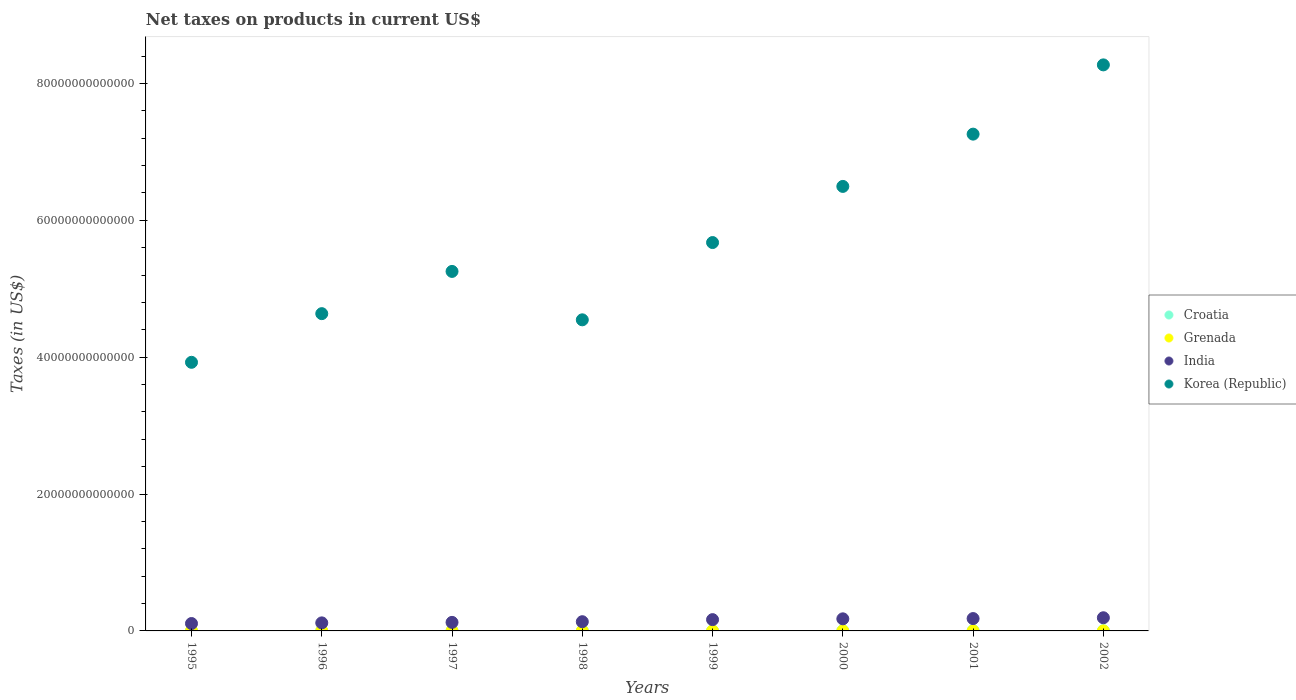How many different coloured dotlines are there?
Your answer should be very brief. 4. What is the net taxes on products in India in 1997?
Make the answer very short. 1.25e+12. Across all years, what is the maximum net taxes on products in Croatia?
Offer a very short reply. 3.54e+1. Across all years, what is the minimum net taxes on products in Grenada?
Offer a very short reply. 1.16e+08. In which year was the net taxes on products in Croatia maximum?
Your answer should be very brief. 2002. What is the total net taxes on products in India in the graph?
Your response must be concise. 1.20e+13. What is the difference between the net taxes on products in Grenada in 1998 and that in 2001?
Keep it short and to the point. -3.16e+07. What is the difference between the net taxes on products in Grenada in 1997 and the net taxes on products in Korea (Republic) in 2000?
Your response must be concise. -6.50e+13. What is the average net taxes on products in Korea (Republic) per year?
Provide a succinct answer. 5.76e+13. In the year 1995, what is the difference between the net taxes on products in India and net taxes on products in Korea (Republic)?
Provide a short and direct response. -3.82e+13. In how many years, is the net taxes on products in Grenada greater than 40000000000000 US$?
Make the answer very short. 0. What is the ratio of the net taxes on products in India in 1998 to that in 2002?
Keep it short and to the point. 0.7. Is the difference between the net taxes on products in India in 1998 and 2000 greater than the difference between the net taxes on products in Korea (Republic) in 1998 and 2000?
Provide a succinct answer. Yes. What is the difference between the highest and the second highest net taxes on products in Croatia?
Provide a short and direct response. 2.80e+09. What is the difference between the highest and the lowest net taxes on products in Croatia?
Offer a terse response. 1.59e+1. In how many years, is the net taxes on products in Korea (Republic) greater than the average net taxes on products in Korea (Republic) taken over all years?
Ensure brevity in your answer.  3. Is it the case that in every year, the sum of the net taxes on products in Croatia and net taxes on products in India  is greater than the sum of net taxes on products in Grenada and net taxes on products in Korea (Republic)?
Your response must be concise. No. Is it the case that in every year, the sum of the net taxes on products in India and net taxes on products in Grenada  is greater than the net taxes on products in Korea (Republic)?
Offer a terse response. No. Does the net taxes on products in Croatia monotonically increase over the years?
Provide a short and direct response. Yes. How many dotlines are there?
Offer a very short reply. 4. How many years are there in the graph?
Your answer should be very brief. 8. What is the difference between two consecutive major ticks on the Y-axis?
Give a very brief answer. 2.00e+13. Are the values on the major ticks of Y-axis written in scientific E-notation?
Your response must be concise. No. Does the graph contain any zero values?
Ensure brevity in your answer.  No. Does the graph contain grids?
Offer a terse response. No. What is the title of the graph?
Your answer should be very brief. Net taxes on products in current US$. Does "Ethiopia" appear as one of the legend labels in the graph?
Offer a very short reply. No. What is the label or title of the X-axis?
Provide a succinct answer. Years. What is the label or title of the Y-axis?
Provide a succinct answer. Taxes (in US$). What is the Taxes (in US$) in Croatia in 1995?
Your response must be concise. 1.95e+1. What is the Taxes (in US$) in Grenada in 1995?
Ensure brevity in your answer.  1.16e+08. What is the Taxes (in US$) in India in 1995?
Make the answer very short. 1.08e+12. What is the Taxes (in US$) in Korea (Republic) in 1995?
Make the answer very short. 3.93e+13. What is the Taxes (in US$) of Croatia in 1996?
Offer a very short reply. 1.99e+1. What is the Taxes (in US$) in Grenada in 1996?
Make the answer very short. 1.32e+08. What is the Taxes (in US$) of India in 1996?
Your answer should be very brief. 1.17e+12. What is the Taxes (in US$) in Korea (Republic) in 1996?
Your answer should be compact. 4.64e+13. What is the Taxes (in US$) of Croatia in 1997?
Your response must be concise. 2.29e+1. What is the Taxes (in US$) in Grenada in 1997?
Ensure brevity in your answer.  1.44e+08. What is the Taxes (in US$) of India in 1997?
Make the answer very short. 1.25e+12. What is the Taxes (in US$) in Korea (Republic) in 1997?
Keep it short and to the point. 5.25e+13. What is the Taxes (in US$) of Croatia in 1998?
Provide a short and direct response. 2.65e+1. What is the Taxes (in US$) of Grenada in 1998?
Your answer should be compact. 1.50e+08. What is the Taxes (in US$) of India in 1998?
Provide a short and direct response. 1.35e+12. What is the Taxes (in US$) of Korea (Republic) in 1998?
Make the answer very short. 4.55e+13. What is the Taxes (in US$) in Croatia in 1999?
Ensure brevity in your answer.  2.66e+1. What is the Taxes (in US$) of Grenada in 1999?
Your answer should be compact. 1.86e+08. What is the Taxes (in US$) in India in 1999?
Your response must be concise. 1.65e+12. What is the Taxes (in US$) in Korea (Republic) in 1999?
Offer a terse response. 5.68e+13. What is the Taxes (in US$) of Croatia in 2000?
Keep it short and to the point. 3.02e+1. What is the Taxes (in US$) in Grenada in 2000?
Give a very brief answer. 1.93e+08. What is the Taxes (in US$) of India in 2000?
Your answer should be very brief. 1.77e+12. What is the Taxes (in US$) in Korea (Republic) in 2000?
Provide a succinct answer. 6.50e+13. What is the Taxes (in US$) of Croatia in 2001?
Offer a terse response. 3.26e+1. What is the Taxes (in US$) of Grenada in 2001?
Your answer should be very brief. 1.82e+08. What is the Taxes (in US$) of India in 2001?
Your answer should be very brief. 1.81e+12. What is the Taxes (in US$) in Korea (Republic) in 2001?
Provide a succinct answer. 7.26e+13. What is the Taxes (in US$) in Croatia in 2002?
Keep it short and to the point. 3.54e+1. What is the Taxes (in US$) of Grenada in 2002?
Provide a short and direct response. 1.90e+08. What is the Taxes (in US$) of India in 2002?
Your answer should be very brief. 1.92e+12. What is the Taxes (in US$) of Korea (Republic) in 2002?
Keep it short and to the point. 8.27e+13. Across all years, what is the maximum Taxes (in US$) of Croatia?
Offer a terse response. 3.54e+1. Across all years, what is the maximum Taxes (in US$) of Grenada?
Offer a terse response. 1.93e+08. Across all years, what is the maximum Taxes (in US$) of India?
Offer a very short reply. 1.92e+12. Across all years, what is the maximum Taxes (in US$) in Korea (Republic)?
Keep it short and to the point. 8.27e+13. Across all years, what is the minimum Taxes (in US$) in Croatia?
Make the answer very short. 1.95e+1. Across all years, what is the minimum Taxes (in US$) in Grenada?
Give a very brief answer. 1.16e+08. Across all years, what is the minimum Taxes (in US$) of India?
Keep it short and to the point. 1.08e+12. Across all years, what is the minimum Taxes (in US$) in Korea (Republic)?
Your response must be concise. 3.93e+13. What is the total Taxes (in US$) in Croatia in the graph?
Make the answer very short. 2.14e+11. What is the total Taxes (in US$) in Grenada in the graph?
Your answer should be compact. 1.29e+09. What is the total Taxes (in US$) of India in the graph?
Make the answer very short. 1.20e+13. What is the total Taxes (in US$) of Korea (Republic) in the graph?
Provide a succinct answer. 4.61e+14. What is the difference between the Taxes (in US$) in Croatia in 1995 and that in 1996?
Give a very brief answer. -3.94e+08. What is the difference between the Taxes (in US$) of Grenada in 1995 and that in 1996?
Offer a very short reply. -1.65e+07. What is the difference between the Taxes (in US$) in India in 1995 and that in 1996?
Your response must be concise. -9.35e+1. What is the difference between the Taxes (in US$) in Korea (Republic) in 1995 and that in 1996?
Make the answer very short. -7.11e+12. What is the difference between the Taxes (in US$) in Croatia in 1995 and that in 1997?
Make the answer very short. -3.39e+09. What is the difference between the Taxes (in US$) in Grenada in 1995 and that in 1997?
Provide a short and direct response. -2.83e+07. What is the difference between the Taxes (in US$) of India in 1995 and that in 1997?
Provide a short and direct response. -1.66e+11. What is the difference between the Taxes (in US$) of Korea (Republic) in 1995 and that in 1997?
Keep it short and to the point. -1.33e+13. What is the difference between the Taxes (in US$) of Croatia in 1995 and that in 1998?
Make the answer very short. -7.04e+09. What is the difference between the Taxes (in US$) in Grenada in 1995 and that in 1998?
Keep it short and to the point. -3.43e+07. What is the difference between the Taxes (in US$) of India in 1995 and that in 1998?
Offer a very short reply. -2.65e+11. What is the difference between the Taxes (in US$) in Korea (Republic) in 1995 and that in 1998?
Offer a terse response. -6.21e+12. What is the difference between the Taxes (in US$) in Croatia in 1995 and that in 1999?
Provide a succinct answer. -7.07e+09. What is the difference between the Taxes (in US$) of Grenada in 1995 and that in 1999?
Ensure brevity in your answer.  -7.06e+07. What is the difference between the Taxes (in US$) of India in 1995 and that in 1999?
Your answer should be compact. -5.68e+11. What is the difference between the Taxes (in US$) of Korea (Republic) in 1995 and that in 1999?
Your response must be concise. -1.75e+13. What is the difference between the Taxes (in US$) in Croatia in 1995 and that in 2000?
Provide a succinct answer. -1.07e+1. What is the difference between the Taxes (in US$) in Grenada in 1995 and that in 2000?
Your answer should be very brief. -7.71e+07. What is the difference between the Taxes (in US$) of India in 1995 and that in 2000?
Your response must be concise. -6.85e+11. What is the difference between the Taxes (in US$) in Korea (Republic) in 1995 and that in 2000?
Keep it short and to the point. -2.57e+13. What is the difference between the Taxes (in US$) in Croatia in 1995 and that in 2001?
Offer a terse response. -1.31e+1. What is the difference between the Taxes (in US$) of Grenada in 1995 and that in 2001?
Provide a short and direct response. -6.59e+07. What is the difference between the Taxes (in US$) in India in 1995 and that in 2001?
Give a very brief answer. -7.24e+11. What is the difference between the Taxes (in US$) in Korea (Republic) in 1995 and that in 2001?
Keep it short and to the point. -3.33e+13. What is the difference between the Taxes (in US$) in Croatia in 1995 and that in 2002?
Keep it short and to the point. -1.59e+1. What is the difference between the Taxes (in US$) in Grenada in 1995 and that in 2002?
Your answer should be compact. -7.42e+07. What is the difference between the Taxes (in US$) in India in 1995 and that in 2002?
Offer a very short reply. -8.43e+11. What is the difference between the Taxes (in US$) in Korea (Republic) in 1995 and that in 2002?
Keep it short and to the point. -4.35e+13. What is the difference between the Taxes (in US$) in Croatia in 1996 and that in 1997?
Provide a short and direct response. -3.00e+09. What is the difference between the Taxes (in US$) of Grenada in 1996 and that in 1997?
Offer a terse response. -1.18e+07. What is the difference between the Taxes (in US$) of India in 1996 and that in 1997?
Your response must be concise. -7.29e+1. What is the difference between the Taxes (in US$) of Korea (Republic) in 1996 and that in 1997?
Your answer should be compact. -6.17e+12. What is the difference between the Taxes (in US$) of Croatia in 1996 and that in 1998?
Provide a succinct answer. -6.65e+09. What is the difference between the Taxes (in US$) in Grenada in 1996 and that in 1998?
Your response must be concise. -1.79e+07. What is the difference between the Taxes (in US$) in India in 1996 and that in 1998?
Your answer should be very brief. -1.72e+11. What is the difference between the Taxes (in US$) of Korea (Republic) in 1996 and that in 1998?
Make the answer very short. 9.02e+11. What is the difference between the Taxes (in US$) of Croatia in 1996 and that in 1999?
Give a very brief answer. -6.68e+09. What is the difference between the Taxes (in US$) of Grenada in 1996 and that in 1999?
Give a very brief answer. -5.42e+07. What is the difference between the Taxes (in US$) in India in 1996 and that in 1999?
Provide a succinct answer. -4.74e+11. What is the difference between the Taxes (in US$) of Korea (Republic) in 1996 and that in 1999?
Give a very brief answer. -1.04e+13. What is the difference between the Taxes (in US$) of Croatia in 1996 and that in 2000?
Make the answer very short. -1.03e+1. What is the difference between the Taxes (in US$) of Grenada in 1996 and that in 2000?
Offer a terse response. -6.06e+07. What is the difference between the Taxes (in US$) of India in 1996 and that in 2000?
Provide a succinct answer. -5.92e+11. What is the difference between the Taxes (in US$) in Korea (Republic) in 1996 and that in 2000?
Offer a very short reply. -1.86e+13. What is the difference between the Taxes (in US$) of Croatia in 1996 and that in 2001?
Offer a terse response. -1.27e+1. What is the difference between the Taxes (in US$) of Grenada in 1996 and that in 2001?
Your answer should be compact. -4.94e+07. What is the difference between the Taxes (in US$) in India in 1996 and that in 2001?
Provide a succinct answer. -6.31e+11. What is the difference between the Taxes (in US$) in Korea (Republic) in 1996 and that in 2001?
Your answer should be compact. -2.62e+13. What is the difference between the Taxes (in US$) of Croatia in 1996 and that in 2002?
Your answer should be compact. -1.55e+1. What is the difference between the Taxes (in US$) of Grenada in 1996 and that in 2002?
Ensure brevity in your answer.  -5.78e+07. What is the difference between the Taxes (in US$) in India in 1996 and that in 2002?
Ensure brevity in your answer.  -7.50e+11. What is the difference between the Taxes (in US$) in Korea (Republic) in 1996 and that in 2002?
Keep it short and to the point. -3.64e+13. What is the difference between the Taxes (in US$) of Croatia in 1997 and that in 1998?
Make the answer very short. -3.65e+09. What is the difference between the Taxes (in US$) of Grenada in 1997 and that in 1998?
Offer a terse response. -6.02e+06. What is the difference between the Taxes (in US$) of India in 1997 and that in 1998?
Give a very brief answer. -9.86e+1. What is the difference between the Taxes (in US$) of Korea (Republic) in 1997 and that in 1998?
Your response must be concise. 7.07e+12. What is the difference between the Taxes (in US$) of Croatia in 1997 and that in 1999?
Keep it short and to the point. -3.68e+09. What is the difference between the Taxes (in US$) in Grenada in 1997 and that in 1999?
Make the answer very short. -4.23e+07. What is the difference between the Taxes (in US$) of India in 1997 and that in 1999?
Ensure brevity in your answer.  -4.01e+11. What is the difference between the Taxes (in US$) in Korea (Republic) in 1997 and that in 1999?
Offer a very short reply. -4.22e+12. What is the difference between the Taxes (in US$) in Croatia in 1997 and that in 2000?
Give a very brief answer. -7.28e+09. What is the difference between the Taxes (in US$) of Grenada in 1997 and that in 2000?
Give a very brief answer. -4.88e+07. What is the difference between the Taxes (in US$) in India in 1997 and that in 2000?
Offer a terse response. -5.19e+11. What is the difference between the Taxes (in US$) of Korea (Republic) in 1997 and that in 2000?
Your answer should be very brief. -1.24e+13. What is the difference between the Taxes (in US$) of Croatia in 1997 and that in 2001?
Ensure brevity in your answer.  -9.72e+09. What is the difference between the Taxes (in US$) of Grenada in 1997 and that in 2001?
Provide a succinct answer. -3.76e+07. What is the difference between the Taxes (in US$) of India in 1997 and that in 2001?
Give a very brief answer. -5.58e+11. What is the difference between the Taxes (in US$) of Korea (Republic) in 1997 and that in 2001?
Your answer should be compact. -2.01e+13. What is the difference between the Taxes (in US$) of Croatia in 1997 and that in 2002?
Your response must be concise. -1.25e+1. What is the difference between the Taxes (in US$) of Grenada in 1997 and that in 2002?
Your answer should be compact. -4.59e+07. What is the difference between the Taxes (in US$) of India in 1997 and that in 2002?
Your response must be concise. -6.77e+11. What is the difference between the Taxes (in US$) in Korea (Republic) in 1997 and that in 2002?
Provide a short and direct response. -3.02e+13. What is the difference between the Taxes (in US$) in Croatia in 1998 and that in 1999?
Provide a succinct answer. -2.80e+07. What is the difference between the Taxes (in US$) in Grenada in 1998 and that in 1999?
Your response must be concise. -3.63e+07. What is the difference between the Taxes (in US$) of India in 1998 and that in 1999?
Offer a very short reply. -3.03e+11. What is the difference between the Taxes (in US$) in Korea (Republic) in 1998 and that in 1999?
Ensure brevity in your answer.  -1.13e+13. What is the difference between the Taxes (in US$) in Croatia in 1998 and that in 2000?
Give a very brief answer. -3.63e+09. What is the difference between the Taxes (in US$) of Grenada in 1998 and that in 2000?
Keep it short and to the point. -4.28e+07. What is the difference between the Taxes (in US$) of India in 1998 and that in 2000?
Offer a terse response. -4.20e+11. What is the difference between the Taxes (in US$) of Korea (Republic) in 1998 and that in 2000?
Give a very brief answer. -1.95e+13. What is the difference between the Taxes (in US$) of Croatia in 1998 and that in 2001?
Give a very brief answer. -6.07e+09. What is the difference between the Taxes (in US$) of Grenada in 1998 and that in 2001?
Make the answer very short. -3.16e+07. What is the difference between the Taxes (in US$) in India in 1998 and that in 2001?
Offer a terse response. -4.59e+11. What is the difference between the Taxes (in US$) of Korea (Republic) in 1998 and that in 2001?
Offer a very short reply. -2.71e+13. What is the difference between the Taxes (in US$) in Croatia in 1998 and that in 2002?
Your answer should be very brief. -8.87e+09. What is the difference between the Taxes (in US$) of Grenada in 1998 and that in 2002?
Ensure brevity in your answer.  -3.99e+07. What is the difference between the Taxes (in US$) in India in 1998 and that in 2002?
Provide a short and direct response. -5.78e+11. What is the difference between the Taxes (in US$) in Korea (Republic) in 1998 and that in 2002?
Provide a short and direct response. -3.73e+13. What is the difference between the Taxes (in US$) of Croatia in 1999 and that in 2000?
Give a very brief answer. -3.60e+09. What is the difference between the Taxes (in US$) of Grenada in 1999 and that in 2000?
Keep it short and to the point. -6.48e+06. What is the difference between the Taxes (in US$) in India in 1999 and that in 2000?
Keep it short and to the point. -1.17e+11. What is the difference between the Taxes (in US$) of Korea (Republic) in 1999 and that in 2000?
Your answer should be compact. -8.20e+12. What is the difference between the Taxes (in US$) in Croatia in 1999 and that in 2001?
Make the answer very short. -6.04e+09. What is the difference between the Taxes (in US$) of Grenada in 1999 and that in 2001?
Keep it short and to the point. 4.73e+06. What is the difference between the Taxes (in US$) of India in 1999 and that in 2001?
Make the answer very short. -1.57e+11. What is the difference between the Taxes (in US$) of Korea (Republic) in 1999 and that in 2001?
Your answer should be very brief. -1.58e+13. What is the difference between the Taxes (in US$) of Croatia in 1999 and that in 2002?
Your answer should be compact. -8.84e+09. What is the difference between the Taxes (in US$) in Grenada in 1999 and that in 2002?
Your answer should be very brief. -3.63e+06. What is the difference between the Taxes (in US$) in India in 1999 and that in 2002?
Provide a short and direct response. -2.75e+11. What is the difference between the Taxes (in US$) in Korea (Republic) in 1999 and that in 2002?
Offer a very short reply. -2.60e+13. What is the difference between the Taxes (in US$) of Croatia in 2000 and that in 2001?
Your answer should be compact. -2.44e+09. What is the difference between the Taxes (in US$) of Grenada in 2000 and that in 2001?
Your answer should be compact. 1.12e+07. What is the difference between the Taxes (in US$) of India in 2000 and that in 2001?
Your answer should be compact. -3.92e+1. What is the difference between the Taxes (in US$) in Korea (Republic) in 2000 and that in 2001?
Keep it short and to the point. -7.64e+12. What is the difference between the Taxes (in US$) of Croatia in 2000 and that in 2002?
Offer a very short reply. -5.24e+09. What is the difference between the Taxes (in US$) in Grenada in 2000 and that in 2002?
Offer a terse response. 2.85e+06. What is the difference between the Taxes (in US$) of India in 2000 and that in 2002?
Make the answer very short. -1.58e+11. What is the difference between the Taxes (in US$) of Korea (Republic) in 2000 and that in 2002?
Provide a short and direct response. -1.78e+13. What is the difference between the Taxes (in US$) of Croatia in 2001 and that in 2002?
Your answer should be compact. -2.80e+09. What is the difference between the Taxes (in US$) in Grenada in 2001 and that in 2002?
Provide a short and direct response. -8.36e+06. What is the difference between the Taxes (in US$) of India in 2001 and that in 2002?
Make the answer very short. -1.19e+11. What is the difference between the Taxes (in US$) in Korea (Republic) in 2001 and that in 2002?
Offer a very short reply. -1.01e+13. What is the difference between the Taxes (in US$) in Croatia in 1995 and the Taxes (in US$) in Grenada in 1996?
Give a very brief answer. 1.94e+1. What is the difference between the Taxes (in US$) of Croatia in 1995 and the Taxes (in US$) of India in 1996?
Ensure brevity in your answer.  -1.16e+12. What is the difference between the Taxes (in US$) in Croatia in 1995 and the Taxes (in US$) in Korea (Republic) in 1996?
Offer a terse response. -4.63e+13. What is the difference between the Taxes (in US$) of Grenada in 1995 and the Taxes (in US$) of India in 1996?
Offer a terse response. -1.17e+12. What is the difference between the Taxes (in US$) of Grenada in 1995 and the Taxes (in US$) of Korea (Republic) in 1996?
Offer a terse response. -4.64e+13. What is the difference between the Taxes (in US$) in India in 1995 and the Taxes (in US$) in Korea (Republic) in 1996?
Offer a very short reply. -4.53e+13. What is the difference between the Taxes (in US$) in Croatia in 1995 and the Taxes (in US$) in Grenada in 1997?
Keep it short and to the point. 1.94e+1. What is the difference between the Taxes (in US$) of Croatia in 1995 and the Taxes (in US$) of India in 1997?
Offer a very short reply. -1.23e+12. What is the difference between the Taxes (in US$) of Croatia in 1995 and the Taxes (in US$) of Korea (Republic) in 1997?
Provide a short and direct response. -5.25e+13. What is the difference between the Taxes (in US$) of Grenada in 1995 and the Taxes (in US$) of India in 1997?
Offer a very short reply. -1.25e+12. What is the difference between the Taxes (in US$) of Grenada in 1995 and the Taxes (in US$) of Korea (Republic) in 1997?
Ensure brevity in your answer.  -5.25e+13. What is the difference between the Taxes (in US$) in India in 1995 and the Taxes (in US$) in Korea (Republic) in 1997?
Provide a succinct answer. -5.15e+13. What is the difference between the Taxes (in US$) in Croatia in 1995 and the Taxes (in US$) in Grenada in 1998?
Your answer should be compact. 1.93e+1. What is the difference between the Taxes (in US$) of Croatia in 1995 and the Taxes (in US$) of India in 1998?
Ensure brevity in your answer.  -1.33e+12. What is the difference between the Taxes (in US$) of Croatia in 1995 and the Taxes (in US$) of Korea (Republic) in 1998?
Ensure brevity in your answer.  -4.54e+13. What is the difference between the Taxes (in US$) in Grenada in 1995 and the Taxes (in US$) in India in 1998?
Offer a very short reply. -1.35e+12. What is the difference between the Taxes (in US$) of Grenada in 1995 and the Taxes (in US$) of Korea (Republic) in 1998?
Your answer should be compact. -4.55e+13. What is the difference between the Taxes (in US$) in India in 1995 and the Taxes (in US$) in Korea (Republic) in 1998?
Give a very brief answer. -4.44e+13. What is the difference between the Taxes (in US$) in Croatia in 1995 and the Taxes (in US$) in Grenada in 1999?
Provide a succinct answer. 1.93e+1. What is the difference between the Taxes (in US$) in Croatia in 1995 and the Taxes (in US$) in India in 1999?
Your answer should be very brief. -1.63e+12. What is the difference between the Taxes (in US$) of Croatia in 1995 and the Taxes (in US$) of Korea (Republic) in 1999?
Keep it short and to the point. -5.67e+13. What is the difference between the Taxes (in US$) in Grenada in 1995 and the Taxes (in US$) in India in 1999?
Provide a short and direct response. -1.65e+12. What is the difference between the Taxes (in US$) in Grenada in 1995 and the Taxes (in US$) in Korea (Republic) in 1999?
Provide a short and direct response. -5.68e+13. What is the difference between the Taxes (in US$) in India in 1995 and the Taxes (in US$) in Korea (Republic) in 1999?
Give a very brief answer. -5.57e+13. What is the difference between the Taxes (in US$) of Croatia in 1995 and the Taxes (in US$) of Grenada in 2000?
Offer a very short reply. 1.93e+1. What is the difference between the Taxes (in US$) in Croatia in 1995 and the Taxes (in US$) in India in 2000?
Your answer should be compact. -1.75e+12. What is the difference between the Taxes (in US$) in Croatia in 1995 and the Taxes (in US$) in Korea (Republic) in 2000?
Offer a terse response. -6.49e+13. What is the difference between the Taxes (in US$) of Grenada in 1995 and the Taxes (in US$) of India in 2000?
Your answer should be very brief. -1.77e+12. What is the difference between the Taxes (in US$) in Grenada in 1995 and the Taxes (in US$) in Korea (Republic) in 2000?
Your response must be concise. -6.50e+13. What is the difference between the Taxes (in US$) of India in 1995 and the Taxes (in US$) of Korea (Republic) in 2000?
Provide a short and direct response. -6.39e+13. What is the difference between the Taxes (in US$) of Croatia in 1995 and the Taxes (in US$) of Grenada in 2001?
Give a very brief answer. 1.93e+1. What is the difference between the Taxes (in US$) in Croatia in 1995 and the Taxes (in US$) in India in 2001?
Your answer should be compact. -1.79e+12. What is the difference between the Taxes (in US$) in Croatia in 1995 and the Taxes (in US$) in Korea (Republic) in 2001?
Your answer should be compact. -7.26e+13. What is the difference between the Taxes (in US$) in Grenada in 1995 and the Taxes (in US$) in India in 2001?
Your answer should be compact. -1.81e+12. What is the difference between the Taxes (in US$) of Grenada in 1995 and the Taxes (in US$) of Korea (Republic) in 2001?
Your answer should be compact. -7.26e+13. What is the difference between the Taxes (in US$) in India in 1995 and the Taxes (in US$) in Korea (Republic) in 2001?
Your answer should be very brief. -7.15e+13. What is the difference between the Taxes (in US$) in Croatia in 1995 and the Taxes (in US$) in Grenada in 2002?
Provide a short and direct response. 1.93e+1. What is the difference between the Taxes (in US$) in Croatia in 1995 and the Taxes (in US$) in India in 2002?
Offer a terse response. -1.91e+12. What is the difference between the Taxes (in US$) in Croatia in 1995 and the Taxes (in US$) in Korea (Republic) in 2002?
Your response must be concise. -8.27e+13. What is the difference between the Taxes (in US$) in Grenada in 1995 and the Taxes (in US$) in India in 2002?
Give a very brief answer. -1.92e+12. What is the difference between the Taxes (in US$) in Grenada in 1995 and the Taxes (in US$) in Korea (Republic) in 2002?
Make the answer very short. -8.27e+13. What is the difference between the Taxes (in US$) of India in 1995 and the Taxes (in US$) of Korea (Republic) in 2002?
Provide a succinct answer. -8.16e+13. What is the difference between the Taxes (in US$) of Croatia in 1996 and the Taxes (in US$) of Grenada in 1997?
Keep it short and to the point. 1.97e+1. What is the difference between the Taxes (in US$) of Croatia in 1996 and the Taxes (in US$) of India in 1997?
Offer a terse response. -1.23e+12. What is the difference between the Taxes (in US$) of Croatia in 1996 and the Taxes (in US$) of Korea (Republic) in 1997?
Make the answer very short. -5.25e+13. What is the difference between the Taxes (in US$) of Grenada in 1996 and the Taxes (in US$) of India in 1997?
Your answer should be compact. -1.25e+12. What is the difference between the Taxes (in US$) of Grenada in 1996 and the Taxes (in US$) of Korea (Republic) in 1997?
Ensure brevity in your answer.  -5.25e+13. What is the difference between the Taxes (in US$) of India in 1996 and the Taxes (in US$) of Korea (Republic) in 1997?
Your response must be concise. -5.14e+13. What is the difference between the Taxes (in US$) of Croatia in 1996 and the Taxes (in US$) of Grenada in 1998?
Give a very brief answer. 1.97e+1. What is the difference between the Taxes (in US$) in Croatia in 1996 and the Taxes (in US$) in India in 1998?
Keep it short and to the point. -1.33e+12. What is the difference between the Taxes (in US$) of Croatia in 1996 and the Taxes (in US$) of Korea (Republic) in 1998?
Your answer should be compact. -4.54e+13. What is the difference between the Taxes (in US$) in Grenada in 1996 and the Taxes (in US$) in India in 1998?
Make the answer very short. -1.35e+12. What is the difference between the Taxes (in US$) in Grenada in 1996 and the Taxes (in US$) in Korea (Republic) in 1998?
Provide a succinct answer. -4.55e+13. What is the difference between the Taxes (in US$) in India in 1996 and the Taxes (in US$) in Korea (Republic) in 1998?
Offer a terse response. -4.43e+13. What is the difference between the Taxes (in US$) in Croatia in 1996 and the Taxes (in US$) in Grenada in 1999?
Provide a short and direct response. 1.97e+1. What is the difference between the Taxes (in US$) in Croatia in 1996 and the Taxes (in US$) in India in 1999?
Your response must be concise. -1.63e+12. What is the difference between the Taxes (in US$) of Croatia in 1996 and the Taxes (in US$) of Korea (Republic) in 1999?
Make the answer very short. -5.67e+13. What is the difference between the Taxes (in US$) in Grenada in 1996 and the Taxes (in US$) in India in 1999?
Give a very brief answer. -1.65e+12. What is the difference between the Taxes (in US$) of Grenada in 1996 and the Taxes (in US$) of Korea (Republic) in 1999?
Give a very brief answer. -5.68e+13. What is the difference between the Taxes (in US$) of India in 1996 and the Taxes (in US$) of Korea (Republic) in 1999?
Ensure brevity in your answer.  -5.56e+13. What is the difference between the Taxes (in US$) of Croatia in 1996 and the Taxes (in US$) of Grenada in 2000?
Ensure brevity in your answer.  1.97e+1. What is the difference between the Taxes (in US$) in Croatia in 1996 and the Taxes (in US$) in India in 2000?
Offer a very short reply. -1.75e+12. What is the difference between the Taxes (in US$) of Croatia in 1996 and the Taxes (in US$) of Korea (Republic) in 2000?
Provide a succinct answer. -6.49e+13. What is the difference between the Taxes (in US$) in Grenada in 1996 and the Taxes (in US$) in India in 2000?
Give a very brief answer. -1.77e+12. What is the difference between the Taxes (in US$) of Grenada in 1996 and the Taxes (in US$) of Korea (Republic) in 2000?
Your answer should be compact. -6.50e+13. What is the difference between the Taxes (in US$) of India in 1996 and the Taxes (in US$) of Korea (Republic) in 2000?
Make the answer very short. -6.38e+13. What is the difference between the Taxes (in US$) of Croatia in 1996 and the Taxes (in US$) of Grenada in 2001?
Give a very brief answer. 1.97e+1. What is the difference between the Taxes (in US$) of Croatia in 1996 and the Taxes (in US$) of India in 2001?
Offer a terse response. -1.79e+12. What is the difference between the Taxes (in US$) of Croatia in 1996 and the Taxes (in US$) of Korea (Republic) in 2001?
Ensure brevity in your answer.  -7.26e+13. What is the difference between the Taxes (in US$) in Grenada in 1996 and the Taxes (in US$) in India in 2001?
Ensure brevity in your answer.  -1.81e+12. What is the difference between the Taxes (in US$) in Grenada in 1996 and the Taxes (in US$) in Korea (Republic) in 2001?
Ensure brevity in your answer.  -7.26e+13. What is the difference between the Taxes (in US$) in India in 1996 and the Taxes (in US$) in Korea (Republic) in 2001?
Your answer should be very brief. -7.14e+13. What is the difference between the Taxes (in US$) in Croatia in 1996 and the Taxes (in US$) in Grenada in 2002?
Keep it short and to the point. 1.97e+1. What is the difference between the Taxes (in US$) in Croatia in 1996 and the Taxes (in US$) in India in 2002?
Offer a terse response. -1.90e+12. What is the difference between the Taxes (in US$) of Croatia in 1996 and the Taxes (in US$) of Korea (Republic) in 2002?
Give a very brief answer. -8.27e+13. What is the difference between the Taxes (in US$) in Grenada in 1996 and the Taxes (in US$) in India in 2002?
Your answer should be very brief. -1.92e+12. What is the difference between the Taxes (in US$) in Grenada in 1996 and the Taxes (in US$) in Korea (Republic) in 2002?
Offer a terse response. -8.27e+13. What is the difference between the Taxes (in US$) in India in 1996 and the Taxes (in US$) in Korea (Republic) in 2002?
Make the answer very short. -8.15e+13. What is the difference between the Taxes (in US$) of Croatia in 1997 and the Taxes (in US$) of Grenada in 1998?
Your response must be concise. 2.27e+1. What is the difference between the Taxes (in US$) of Croatia in 1997 and the Taxes (in US$) of India in 1998?
Keep it short and to the point. -1.32e+12. What is the difference between the Taxes (in US$) in Croatia in 1997 and the Taxes (in US$) in Korea (Republic) in 1998?
Make the answer very short. -4.54e+13. What is the difference between the Taxes (in US$) in Grenada in 1997 and the Taxes (in US$) in India in 1998?
Your answer should be compact. -1.35e+12. What is the difference between the Taxes (in US$) in Grenada in 1997 and the Taxes (in US$) in Korea (Republic) in 1998?
Offer a very short reply. -4.55e+13. What is the difference between the Taxes (in US$) in India in 1997 and the Taxes (in US$) in Korea (Republic) in 1998?
Give a very brief answer. -4.42e+13. What is the difference between the Taxes (in US$) of Croatia in 1997 and the Taxes (in US$) of Grenada in 1999?
Offer a very short reply. 2.27e+1. What is the difference between the Taxes (in US$) of Croatia in 1997 and the Taxes (in US$) of India in 1999?
Your answer should be compact. -1.63e+12. What is the difference between the Taxes (in US$) of Croatia in 1997 and the Taxes (in US$) of Korea (Republic) in 1999?
Your answer should be very brief. -5.67e+13. What is the difference between the Taxes (in US$) in Grenada in 1997 and the Taxes (in US$) in India in 1999?
Ensure brevity in your answer.  -1.65e+12. What is the difference between the Taxes (in US$) of Grenada in 1997 and the Taxes (in US$) of Korea (Republic) in 1999?
Provide a succinct answer. -5.68e+13. What is the difference between the Taxes (in US$) of India in 1997 and the Taxes (in US$) of Korea (Republic) in 1999?
Your response must be concise. -5.55e+13. What is the difference between the Taxes (in US$) of Croatia in 1997 and the Taxes (in US$) of Grenada in 2000?
Give a very brief answer. 2.27e+1. What is the difference between the Taxes (in US$) in Croatia in 1997 and the Taxes (in US$) in India in 2000?
Your answer should be compact. -1.74e+12. What is the difference between the Taxes (in US$) in Croatia in 1997 and the Taxes (in US$) in Korea (Republic) in 2000?
Provide a succinct answer. -6.49e+13. What is the difference between the Taxes (in US$) of Grenada in 1997 and the Taxes (in US$) of India in 2000?
Offer a terse response. -1.77e+12. What is the difference between the Taxes (in US$) in Grenada in 1997 and the Taxes (in US$) in Korea (Republic) in 2000?
Keep it short and to the point. -6.50e+13. What is the difference between the Taxes (in US$) in India in 1997 and the Taxes (in US$) in Korea (Republic) in 2000?
Your answer should be very brief. -6.37e+13. What is the difference between the Taxes (in US$) of Croatia in 1997 and the Taxes (in US$) of Grenada in 2001?
Keep it short and to the point. 2.27e+1. What is the difference between the Taxes (in US$) in Croatia in 1997 and the Taxes (in US$) in India in 2001?
Provide a short and direct response. -1.78e+12. What is the difference between the Taxes (in US$) of Croatia in 1997 and the Taxes (in US$) of Korea (Republic) in 2001?
Ensure brevity in your answer.  -7.26e+13. What is the difference between the Taxes (in US$) in Grenada in 1997 and the Taxes (in US$) in India in 2001?
Keep it short and to the point. -1.81e+12. What is the difference between the Taxes (in US$) in Grenada in 1997 and the Taxes (in US$) in Korea (Republic) in 2001?
Provide a succinct answer. -7.26e+13. What is the difference between the Taxes (in US$) in India in 1997 and the Taxes (in US$) in Korea (Republic) in 2001?
Your answer should be compact. -7.14e+13. What is the difference between the Taxes (in US$) in Croatia in 1997 and the Taxes (in US$) in Grenada in 2002?
Your response must be concise. 2.27e+1. What is the difference between the Taxes (in US$) of Croatia in 1997 and the Taxes (in US$) of India in 2002?
Your response must be concise. -1.90e+12. What is the difference between the Taxes (in US$) of Croatia in 1997 and the Taxes (in US$) of Korea (Republic) in 2002?
Your response must be concise. -8.27e+13. What is the difference between the Taxes (in US$) in Grenada in 1997 and the Taxes (in US$) in India in 2002?
Keep it short and to the point. -1.92e+12. What is the difference between the Taxes (in US$) of Grenada in 1997 and the Taxes (in US$) of Korea (Republic) in 2002?
Give a very brief answer. -8.27e+13. What is the difference between the Taxes (in US$) in India in 1997 and the Taxes (in US$) in Korea (Republic) in 2002?
Give a very brief answer. -8.15e+13. What is the difference between the Taxes (in US$) of Croatia in 1998 and the Taxes (in US$) of Grenada in 1999?
Provide a short and direct response. 2.64e+1. What is the difference between the Taxes (in US$) in Croatia in 1998 and the Taxes (in US$) in India in 1999?
Your response must be concise. -1.62e+12. What is the difference between the Taxes (in US$) of Croatia in 1998 and the Taxes (in US$) of Korea (Republic) in 1999?
Your answer should be compact. -5.67e+13. What is the difference between the Taxes (in US$) in Grenada in 1998 and the Taxes (in US$) in India in 1999?
Offer a very short reply. -1.65e+12. What is the difference between the Taxes (in US$) in Grenada in 1998 and the Taxes (in US$) in Korea (Republic) in 1999?
Provide a short and direct response. -5.68e+13. What is the difference between the Taxes (in US$) in India in 1998 and the Taxes (in US$) in Korea (Republic) in 1999?
Make the answer very short. -5.54e+13. What is the difference between the Taxes (in US$) of Croatia in 1998 and the Taxes (in US$) of Grenada in 2000?
Offer a terse response. 2.63e+1. What is the difference between the Taxes (in US$) of Croatia in 1998 and the Taxes (in US$) of India in 2000?
Provide a succinct answer. -1.74e+12. What is the difference between the Taxes (in US$) of Croatia in 1998 and the Taxes (in US$) of Korea (Republic) in 2000?
Provide a short and direct response. -6.49e+13. What is the difference between the Taxes (in US$) in Grenada in 1998 and the Taxes (in US$) in India in 2000?
Give a very brief answer. -1.77e+12. What is the difference between the Taxes (in US$) of Grenada in 1998 and the Taxes (in US$) of Korea (Republic) in 2000?
Keep it short and to the point. -6.50e+13. What is the difference between the Taxes (in US$) of India in 1998 and the Taxes (in US$) of Korea (Republic) in 2000?
Provide a short and direct response. -6.36e+13. What is the difference between the Taxes (in US$) in Croatia in 1998 and the Taxes (in US$) in Grenada in 2001?
Offer a very short reply. 2.64e+1. What is the difference between the Taxes (in US$) of Croatia in 1998 and the Taxes (in US$) of India in 2001?
Ensure brevity in your answer.  -1.78e+12. What is the difference between the Taxes (in US$) of Croatia in 1998 and the Taxes (in US$) of Korea (Republic) in 2001?
Provide a short and direct response. -7.26e+13. What is the difference between the Taxes (in US$) in Grenada in 1998 and the Taxes (in US$) in India in 2001?
Your answer should be very brief. -1.81e+12. What is the difference between the Taxes (in US$) of Grenada in 1998 and the Taxes (in US$) of Korea (Republic) in 2001?
Provide a succinct answer. -7.26e+13. What is the difference between the Taxes (in US$) of India in 1998 and the Taxes (in US$) of Korea (Republic) in 2001?
Offer a very short reply. -7.13e+13. What is the difference between the Taxes (in US$) of Croatia in 1998 and the Taxes (in US$) of Grenada in 2002?
Give a very brief answer. 2.64e+1. What is the difference between the Taxes (in US$) in Croatia in 1998 and the Taxes (in US$) in India in 2002?
Ensure brevity in your answer.  -1.90e+12. What is the difference between the Taxes (in US$) of Croatia in 1998 and the Taxes (in US$) of Korea (Republic) in 2002?
Keep it short and to the point. -8.27e+13. What is the difference between the Taxes (in US$) of Grenada in 1998 and the Taxes (in US$) of India in 2002?
Make the answer very short. -1.92e+12. What is the difference between the Taxes (in US$) in Grenada in 1998 and the Taxes (in US$) in Korea (Republic) in 2002?
Keep it short and to the point. -8.27e+13. What is the difference between the Taxes (in US$) of India in 1998 and the Taxes (in US$) of Korea (Republic) in 2002?
Offer a terse response. -8.14e+13. What is the difference between the Taxes (in US$) in Croatia in 1999 and the Taxes (in US$) in Grenada in 2000?
Keep it short and to the point. 2.64e+1. What is the difference between the Taxes (in US$) in Croatia in 1999 and the Taxes (in US$) in India in 2000?
Provide a short and direct response. -1.74e+12. What is the difference between the Taxes (in US$) in Croatia in 1999 and the Taxes (in US$) in Korea (Republic) in 2000?
Your response must be concise. -6.49e+13. What is the difference between the Taxes (in US$) in Grenada in 1999 and the Taxes (in US$) in India in 2000?
Offer a very short reply. -1.77e+12. What is the difference between the Taxes (in US$) of Grenada in 1999 and the Taxes (in US$) of Korea (Republic) in 2000?
Ensure brevity in your answer.  -6.50e+13. What is the difference between the Taxes (in US$) in India in 1999 and the Taxes (in US$) in Korea (Republic) in 2000?
Your response must be concise. -6.33e+13. What is the difference between the Taxes (in US$) in Croatia in 1999 and the Taxes (in US$) in Grenada in 2001?
Your answer should be compact. 2.64e+1. What is the difference between the Taxes (in US$) of Croatia in 1999 and the Taxes (in US$) of India in 2001?
Keep it short and to the point. -1.78e+12. What is the difference between the Taxes (in US$) of Croatia in 1999 and the Taxes (in US$) of Korea (Republic) in 2001?
Provide a short and direct response. -7.26e+13. What is the difference between the Taxes (in US$) of Grenada in 1999 and the Taxes (in US$) of India in 2001?
Offer a terse response. -1.81e+12. What is the difference between the Taxes (in US$) in Grenada in 1999 and the Taxes (in US$) in Korea (Republic) in 2001?
Offer a terse response. -7.26e+13. What is the difference between the Taxes (in US$) in India in 1999 and the Taxes (in US$) in Korea (Republic) in 2001?
Offer a very short reply. -7.10e+13. What is the difference between the Taxes (in US$) of Croatia in 1999 and the Taxes (in US$) of Grenada in 2002?
Offer a very short reply. 2.64e+1. What is the difference between the Taxes (in US$) in Croatia in 1999 and the Taxes (in US$) in India in 2002?
Offer a terse response. -1.90e+12. What is the difference between the Taxes (in US$) of Croatia in 1999 and the Taxes (in US$) of Korea (Republic) in 2002?
Offer a very short reply. -8.27e+13. What is the difference between the Taxes (in US$) in Grenada in 1999 and the Taxes (in US$) in India in 2002?
Offer a terse response. -1.92e+12. What is the difference between the Taxes (in US$) of Grenada in 1999 and the Taxes (in US$) of Korea (Republic) in 2002?
Provide a short and direct response. -8.27e+13. What is the difference between the Taxes (in US$) in India in 1999 and the Taxes (in US$) in Korea (Republic) in 2002?
Ensure brevity in your answer.  -8.11e+13. What is the difference between the Taxes (in US$) of Croatia in 2000 and the Taxes (in US$) of Grenada in 2001?
Keep it short and to the point. 3.00e+1. What is the difference between the Taxes (in US$) of Croatia in 2000 and the Taxes (in US$) of India in 2001?
Your response must be concise. -1.78e+12. What is the difference between the Taxes (in US$) in Croatia in 2000 and the Taxes (in US$) in Korea (Republic) in 2001?
Provide a short and direct response. -7.26e+13. What is the difference between the Taxes (in US$) of Grenada in 2000 and the Taxes (in US$) of India in 2001?
Offer a very short reply. -1.81e+12. What is the difference between the Taxes (in US$) in Grenada in 2000 and the Taxes (in US$) in Korea (Republic) in 2001?
Provide a succinct answer. -7.26e+13. What is the difference between the Taxes (in US$) of India in 2000 and the Taxes (in US$) of Korea (Republic) in 2001?
Offer a very short reply. -7.08e+13. What is the difference between the Taxes (in US$) of Croatia in 2000 and the Taxes (in US$) of Grenada in 2002?
Provide a short and direct response. 3.00e+1. What is the difference between the Taxes (in US$) of Croatia in 2000 and the Taxes (in US$) of India in 2002?
Your response must be concise. -1.89e+12. What is the difference between the Taxes (in US$) in Croatia in 2000 and the Taxes (in US$) in Korea (Republic) in 2002?
Provide a succinct answer. -8.27e+13. What is the difference between the Taxes (in US$) of Grenada in 2000 and the Taxes (in US$) of India in 2002?
Ensure brevity in your answer.  -1.92e+12. What is the difference between the Taxes (in US$) of Grenada in 2000 and the Taxes (in US$) of Korea (Republic) in 2002?
Provide a short and direct response. -8.27e+13. What is the difference between the Taxes (in US$) in India in 2000 and the Taxes (in US$) in Korea (Republic) in 2002?
Offer a very short reply. -8.10e+13. What is the difference between the Taxes (in US$) in Croatia in 2001 and the Taxes (in US$) in Grenada in 2002?
Your answer should be compact. 3.24e+1. What is the difference between the Taxes (in US$) in Croatia in 2001 and the Taxes (in US$) in India in 2002?
Ensure brevity in your answer.  -1.89e+12. What is the difference between the Taxes (in US$) in Croatia in 2001 and the Taxes (in US$) in Korea (Republic) in 2002?
Your response must be concise. -8.27e+13. What is the difference between the Taxes (in US$) in Grenada in 2001 and the Taxes (in US$) in India in 2002?
Offer a very short reply. -1.92e+12. What is the difference between the Taxes (in US$) in Grenada in 2001 and the Taxes (in US$) in Korea (Republic) in 2002?
Provide a succinct answer. -8.27e+13. What is the difference between the Taxes (in US$) in India in 2001 and the Taxes (in US$) in Korea (Republic) in 2002?
Offer a terse response. -8.09e+13. What is the average Taxes (in US$) in Croatia per year?
Make the answer very short. 2.67e+1. What is the average Taxes (in US$) in Grenada per year?
Make the answer very short. 1.62e+08. What is the average Taxes (in US$) of India per year?
Your answer should be very brief. 1.50e+12. What is the average Taxes (in US$) of Korea (Republic) per year?
Provide a short and direct response. 5.76e+13. In the year 1995, what is the difference between the Taxes (in US$) of Croatia and Taxes (in US$) of Grenada?
Keep it short and to the point. 1.94e+1. In the year 1995, what is the difference between the Taxes (in US$) of Croatia and Taxes (in US$) of India?
Provide a succinct answer. -1.06e+12. In the year 1995, what is the difference between the Taxes (in US$) in Croatia and Taxes (in US$) in Korea (Republic)?
Give a very brief answer. -3.92e+13. In the year 1995, what is the difference between the Taxes (in US$) in Grenada and Taxes (in US$) in India?
Offer a terse response. -1.08e+12. In the year 1995, what is the difference between the Taxes (in US$) of Grenada and Taxes (in US$) of Korea (Republic)?
Ensure brevity in your answer.  -3.93e+13. In the year 1995, what is the difference between the Taxes (in US$) of India and Taxes (in US$) of Korea (Republic)?
Ensure brevity in your answer.  -3.82e+13. In the year 1996, what is the difference between the Taxes (in US$) of Croatia and Taxes (in US$) of Grenada?
Give a very brief answer. 1.98e+1. In the year 1996, what is the difference between the Taxes (in US$) in Croatia and Taxes (in US$) in India?
Your response must be concise. -1.15e+12. In the year 1996, what is the difference between the Taxes (in US$) of Croatia and Taxes (in US$) of Korea (Republic)?
Your response must be concise. -4.63e+13. In the year 1996, what is the difference between the Taxes (in US$) in Grenada and Taxes (in US$) in India?
Your answer should be compact. -1.17e+12. In the year 1996, what is the difference between the Taxes (in US$) in Grenada and Taxes (in US$) in Korea (Republic)?
Keep it short and to the point. -4.64e+13. In the year 1996, what is the difference between the Taxes (in US$) of India and Taxes (in US$) of Korea (Republic)?
Ensure brevity in your answer.  -4.52e+13. In the year 1997, what is the difference between the Taxes (in US$) of Croatia and Taxes (in US$) of Grenada?
Provide a succinct answer. 2.27e+1. In the year 1997, what is the difference between the Taxes (in US$) in Croatia and Taxes (in US$) in India?
Provide a short and direct response. -1.22e+12. In the year 1997, what is the difference between the Taxes (in US$) in Croatia and Taxes (in US$) in Korea (Republic)?
Give a very brief answer. -5.25e+13. In the year 1997, what is the difference between the Taxes (in US$) in Grenada and Taxes (in US$) in India?
Provide a short and direct response. -1.25e+12. In the year 1997, what is the difference between the Taxes (in US$) in Grenada and Taxes (in US$) in Korea (Republic)?
Your answer should be very brief. -5.25e+13. In the year 1997, what is the difference between the Taxes (in US$) in India and Taxes (in US$) in Korea (Republic)?
Your response must be concise. -5.13e+13. In the year 1998, what is the difference between the Taxes (in US$) in Croatia and Taxes (in US$) in Grenada?
Offer a very short reply. 2.64e+1. In the year 1998, what is the difference between the Taxes (in US$) in Croatia and Taxes (in US$) in India?
Offer a very short reply. -1.32e+12. In the year 1998, what is the difference between the Taxes (in US$) of Croatia and Taxes (in US$) of Korea (Republic)?
Ensure brevity in your answer.  -4.54e+13. In the year 1998, what is the difference between the Taxes (in US$) in Grenada and Taxes (in US$) in India?
Ensure brevity in your answer.  -1.35e+12. In the year 1998, what is the difference between the Taxes (in US$) of Grenada and Taxes (in US$) of Korea (Republic)?
Ensure brevity in your answer.  -4.55e+13. In the year 1998, what is the difference between the Taxes (in US$) in India and Taxes (in US$) in Korea (Republic)?
Ensure brevity in your answer.  -4.41e+13. In the year 1999, what is the difference between the Taxes (in US$) of Croatia and Taxes (in US$) of Grenada?
Make the answer very short. 2.64e+1. In the year 1999, what is the difference between the Taxes (in US$) in Croatia and Taxes (in US$) in India?
Offer a terse response. -1.62e+12. In the year 1999, what is the difference between the Taxes (in US$) of Croatia and Taxes (in US$) of Korea (Republic)?
Give a very brief answer. -5.67e+13. In the year 1999, what is the difference between the Taxes (in US$) of Grenada and Taxes (in US$) of India?
Your answer should be compact. -1.65e+12. In the year 1999, what is the difference between the Taxes (in US$) of Grenada and Taxes (in US$) of Korea (Republic)?
Give a very brief answer. -5.68e+13. In the year 1999, what is the difference between the Taxes (in US$) in India and Taxes (in US$) in Korea (Republic)?
Provide a short and direct response. -5.51e+13. In the year 2000, what is the difference between the Taxes (in US$) of Croatia and Taxes (in US$) of Grenada?
Give a very brief answer. 3.00e+1. In the year 2000, what is the difference between the Taxes (in US$) in Croatia and Taxes (in US$) in India?
Offer a terse response. -1.74e+12. In the year 2000, what is the difference between the Taxes (in US$) in Croatia and Taxes (in US$) in Korea (Republic)?
Offer a terse response. -6.49e+13. In the year 2000, what is the difference between the Taxes (in US$) of Grenada and Taxes (in US$) of India?
Your response must be concise. -1.77e+12. In the year 2000, what is the difference between the Taxes (in US$) in Grenada and Taxes (in US$) in Korea (Republic)?
Offer a very short reply. -6.50e+13. In the year 2000, what is the difference between the Taxes (in US$) in India and Taxes (in US$) in Korea (Republic)?
Your answer should be compact. -6.32e+13. In the year 2001, what is the difference between the Taxes (in US$) in Croatia and Taxes (in US$) in Grenada?
Offer a very short reply. 3.24e+1. In the year 2001, what is the difference between the Taxes (in US$) of Croatia and Taxes (in US$) of India?
Keep it short and to the point. -1.77e+12. In the year 2001, what is the difference between the Taxes (in US$) in Croatia and Taxes (in US$) in Korea (Republic)?
Your response must be concise. -7.26e+13. In the year 2001, what is the difference between the Taxes (in US$) in Grenada and Taxes (in US$) in India?
Ensure brevity in your answer.  -1.81e+12. In the year 2001, what is the difference between the Taxes (in US$) in Grenada and Taxes (in US$) in Korea (Republic)?
Your response must be concise. -7.26e+13. In the year 2001, what is the difference between the Taxes (in US$) in India and Taxes (in US$) in Korea (Republic)?
Offer a terse response. -7.08e+13. In the year 2002, what is the difference between the Taxes (in US$) in Croatia and Taxes (in US$) in Grenada?
Keep it short and to the point. 3.52e+1. In the year 2002, what is the difference between the Taxes (in US$) in Croatia and Taxes (in US$) in India?
Your answer should be very brief. -1.89e+12. In the year 2002, what is the difference between the Taxes (in US$) in Croatia and Taxes (in US$) in Korea (Republic)?
Provide a short and direct response. -8.27e+13. In the year 2002, what is the difference between the Taxes (in US$) in Grenada and Taxes (in US$) in India?
Your response must be concise. -1.92e+12. In the year 2002, what is the difference between the Taxes (in US$) of Grenada and Taxes (in US$) of Korea (Republic)?
Offer a very short reply. -8.27e+13. In the year 2002, what is the difference between the Taxes (in US$) in India and Taxes (in US$) in Korea (Republic)?
Provide a short and direct response. -8.08e+13. What is the ratio of the Taxes (in US$) in Croatia in 1995 to that in 1996?
Offer a terse response. 0.98. What is the ratio of the Taxes (in US$) in Grenada in 1995 to that in 1996?
Provide a short and direct response. 0.88. What is the ratio of the Taxes (in US$) of India in 1995 to that in 1996?
Your response must be concise. 0.92. What is the ratio of the Taxes (in US$) of Korea (Republic) in 1995 to that in 1996?
Give a very brief answer. 0.85. What is the ratio of the Taxes (in US$) in Croatia in 1995 to that in 1997?
Keep it short and to the point. 0.85. What is the ratio of the Taxes (in US$) of Grenada in 1995 to that in 1997?
Keep it short and to the point. 0.8. What is the ratio of the Taxes (in US$) of India in 1995 to that in 1997?
Offer a terse response. 0.87. What is the ratio of the Taxes (in US$) of Korea (Republic) in 1995 to that in 1997?
Ensure brevity in your answer.  0.75. What is the ratio of the Taxes (in US$) of Croatia in 1995 to that in 1998?
Your answer should be compact. 0.73. What is the ratio of the Taxes (in US$) of Grenada in 1995 to that in 1998?
Give a very brief answer. 0.77. What is the ratio of the Taxes (in US$) in India in 1995 to that in 1998?
Ensure brevity in your answer.  0.8. What is the ratio of the Taxes (in US$) of Korea (Republic) in 1995 to that in 1998?
Ensure brevity in your answer.  0.86. What is the ratio of the Taxes (in US$) of Croatia in 1995 to that in 1999?
Offer a very short reply. 0.73. What is the ratio of the Taxes (in US$) in Grenada in 1995 to that in 1999?
Your response must be concise. 0.62. What is the ratio of the Taxes (in US$) in India in 1995 to that in 1999?
Ensure brevity in your answer.  0.66. What is the ratio of the Taxes (in US$) of Korea (Republic) in 1995 to that in 1999?
Your response must be concise. 0.69. What is the ratio of the Taxes (in US$) in Croatia in 1995 to that in 2000?
Offer a very short reply. 0.65. What is the ratio of the Taxes (in US$) of Grenada in 1995 to that in 2000?
Your answer should be very brief. 0.6. What is the ratio of the Taxes (in US$) in India in 1995 to that in 2000?
Your answer should be compact. 0.61. What is the ratio of the Taxes (in US$) in Korea (Republic) in 1995 to that in 2000?
Give a very brief answer. 0.6. What is the ratio of the Taxes (in US$) in Croatia in 1995 to that in 2001?
Keep it short and to the point. 0.6. What is the ratio of the Taxes (in US$) of Grenada in 1995 to that in 2001?
Ensure brevity in your answer.  0.64. What is the ratio of the Taxes (in US$) in India in 1995 to that in 2001?
Ensure brevity in your answer.  0.6. What is the ratio of the Taxes (in US$) in Korea (Republic) in 1995 to that in 2001?
Offer a terse response. 0.54. What is the ratio of the Taxes (in US$) of Croatia in 1995 to that in 2002?
Give a very brief answer. 0.55. What is the ratio of the Taxes (in US$) of Grenada in 1995 to that in 2002?
Offer a terse response. 0.61. What is the ratio of the Taxes (in US$) in India in 1995 to that in 2002?
Give a very brief answer. 0.56. What is the ratio of the Taxes (in US$) in Korea (Republic) in 1995 to that in 2002?
Offer a terse response. 0.47. What is the ratio of the Taxes (in US$) of Croatia in 1996 to that in 1997?
Your answer should be very brief. 0.87. What is the ratio of the Taxes (in US$) in Grenada in 1996 to that in 1997?
Offer a very short reply. 0.92. What is the ratio of the Taxes (in US$) in India in 1996 to that in 1997?
Give a very brief answer. 0.94. What is the ratio of the Taxes (in US$) of Korea (Republic) in 1996 to that in 1997?
Provide a succinct answer. 0.88. What is the ratio of the Taxes (in US$) of Croatia in 1996 to that in 1998?
Make the answer very short. 0.75. What is the ratio of the Taxes (in US$) in Grenada in 1996 to that in 1998?
Give a very brief answer. 0.88. What is the ratio of the Taxes (in US$) of India in 1996 to that in 1998?
Offer a terse response. 0.87. What is the ratio of the Taxes (in US$) in Korea (Republic) in 1996 to that in 1998?
Make the answer very short. 1.02. What is the ratio of the Taxes (in US$) in Croatia in 1996 to that in 1999?
Give a very brief answer. 0.75. What is the ratio of the Taxes (in US$) in Grenada in 1996 to that in 1999?
Provide a short and direct response. 0.71. What is the ratio of the Taxes (in US$) in India in 1996 to that in 1999?
Keep it short and to the point. 0.71. What is the ratio of the Taxes (in US$) in Korea (Republic) in 1996 to that in 1999?
Your answer should be compact. 0.82. What is the ratio of the Taxes (in US$) in Croatia in 1996 to that in 2000?
Offer a terse response. 0.66. What is the ratio of the Taxes (in US$) in Grenada in 1996 to that in 2000?
Your answer should be compact. 0.69. What is the ratio of the Taxes (in US$) in India in 1996 to that in 2000?
Ensure brevity in your answer.  0.67. What is the ratio of the Taxes (in US$) of Korea (Republic) in 1996 to that in 2000?
Your answer should be compact. 0.71. What is the ratio of the Taxes (in US$) in Croatia in 1996 to that in 2001?
Ensure brevity in your answer.  0.61. What is the ratio of the Taxes (in US$) in Grenada in 1996 to that in 2001?
Your response must be concise. 0.73. What is the ratio of the Taxes (in US$) in India in 1996 to that in 2001?
Give a very brief answer. 0.65. What is the ratio of the Taxes (in US$) in Korea (Republic) in 1996 to that in 2001?
Your answer should be very brief. 0.64. What is the ratio of the Taxes (in US$) in Croatia in 1996 to that in 2002?
Keep it short and to the point. 0.56. What is the ratio of the Taxes (in US$) of Grenada in 1996 to that in 2002?
Provide a short and direct response. 0.7. What is the ratio of the Taxes (in US$) in India in 1996 to that in 2002?
Offer a very short reply. 0.61. What is the ratio of the Taxes (in US$) in Korea (Republic) in 1996 to that in 2002?
Your answer should be very brief. 0.56. What is the ratio of the Taxes (in US$) in Croatia in 1997 to that in 1998?
Your answer should be very brief. 0.86. What is the ratio of the Taxes (in US$) of Grenada in 1997 to that in 1998?
Ensure brevity in your answer.  0.96. What is the ratio of the Taxes (in US$) in India in 1997 to that in 1998?
Offer a terse response. 0.93. What is the ratio of the Taxes (in US$) in Korea (Republic) in 1997 to that in 1998?
Provide a short and direct response. 1.16. What is the ratio of the Taxes (in US$) in Croatia in 1997 to that in 1999?
Keep it short and to the point. 0.86. What is the ratio of the Taxes (in US$) of Grenada in 1997 to that in 1999?
Your answer should be very brief. 0.77. What is the ratio of the Taxes (in US$) in India in 1997 to that in 1999?
Ensure brevity in your answer.  0.76. What is the ratio of the Taxes (in US$) in Korea (Republic) in 1997 to that in 1999?
Your response must be concise. 0.93. What is the ratio of the Taxes (in US$) in Croatia in 1997 to that in 2000?
Provide a short and direct response. 0.76. What is the ratio of the Taxes (in US$) in Grenada in 1997 to that in 2000?
Your response must be concise. 0.75. What is the ratio of the Taxes (in US$) of India in 1997 to that in 2000?
Make the answer very short. 0.71. What is the ratio of the Taxes (in US$) of Korea (Republic) in 1997 to that in 2000?
Ensure brevity in your answer.  0.81. What is the ratio of the Taxes (in US$) in Croatia in 1997 to that in 2001?
Keep it short and to the point. 0.7. What is the ratio of the Taxes (in US$) in Grenada in 1997 to that in 2001?
Keep it short and to the point. 0.79. What is the ratio of the Taxes (in US$) of India in 1997 to that in 2001?
Give a very brief answer. 0.69. What is the ratio of the Taxes (in US$) of Korea (Republic) in 1997 to that in 2001?
Provide a short and direct response. 0.72. What is the ratio of the Taxes (in US$) in Croatia in 1997 to that in 2002?
Ensure brevity in your answer.  0.65. What is the ratio of the Taxes (in US$) of Grenada in 1997 to that in 2002?
Your response must be concise. 0.76. What is the ratio of the Taxes (in US$) of India in 1997 to that in 2002?
Keep it short and to the point. 0.65. What is the ratio of the Taxes (in US$) in Korea (Republic) in 1997 to that in 2002?
Offer a terse response. 0.64. What is the ratio of the Taxes (in US$) of Grenada in 1998 to that in 1999?
Provide a short and direct response. 0.81. What is the ratio of the Taxes (in US$) in India in 1998 to that in 1999?
Your answer should be very brief. 0.82. What is the ratio of the Taxes (in US$) in Korea (Republic) in 1998 to that in 1999?
Your response must be concise. 0.8. What is the ratio of the Taxes (in US$) in Croatia in 1998 to that in 2000?
Provide a short and direct response. 0.88. What is the ratio of the Taxes (in US$) in Grenada in 1998 to that in 2000?
Give a very brief answer. 0.78. What is the ratio of the Taxes (in US$) in India in 1998 to that in 2000?
Your answer should be very brief. 0.76. What is the ratio of the Taxes (in US$) in Korea (Republic) in 1998 to that in 2000?
Your answer should be very brief. 0.7. What is the ratio of the Taxes (in US$) in Croatia in 1998 to that in 2001?
Your answer should be compact. 0.81. What is the ratio of the Taxes (in US$) in Grenada in 1998 to that in 2001?
Keep it short and to the point. 0.83. What is the ratio of the Taxes (in US$) of India in 1998 to that in 2001?
Your answer should be very brief. 0.75. What is the ratio of the Taxes (in US$) of Korea (Republic) in 1998 to that in 2001?
Provide a short and direct response. 0.63. What is the ratio of the Taxes (in US$) of Croatia in 1998 to that in 2002?
Your response must be concise. 0.75. What is the ratio of the Taxes (in US$) of Grenada in 1998 to that in 2002?
Your response must be concise. 0.79. What is the ratio of the Taxes (in US$) of India in 1998 to that in 2002?
Provide a succinct answer. 0.7. What is the ratio of the Taxes (in US$) in Korea (Republic) in 1998 to that in 2002?
Give a very brief answer. 0.55. What is the ratio of the Taxes (in US$) in Croatia in 1999 to that in 2000?
Make the answer very short. 0.88. What is the ratio of the Taxes (in US$) of Grenada in 1999 to that in 2000?
Your answer should be very brief. 0.97. What is the ratio of the Taxes (in US$) in India in 1999 to that in 2000?
Your response must be concise. 0.93. What is the ratio of the Taxes (in US$) of Korea (Republic) in 1999 to that in 2000?
Provide a short and direct response. 0.87. What is the ratio of the Taxes (in US$) in Croatia in 1999 to that in 2001?
Keep it short and to the point. 0.81. What is the ratio of the Taxes (in US$) in India in 1999 to that in 2001?
Provide a succinct answer. 0.91. What is the ratio of the Taxes (in US$) in Korea (Republic) in 1999 to that in 2001?
Provide a succinct answer. 0.78. What is the ratio of the Taxes (in US$) of Croatia in 1999 to that in 2002?
Your response must be concise. 0.75. What is the ratio of the Taxes (in US$) of Grenada in 1999 to that in 2002?
Your answer should be compact. 0.98. What is the ratio of the Taxes (in US$) of India in 1999 to that in 2002?
Offer a terse response. 0.86. What is the ratio of the Taxes (in US$) in Korea (Republic) in 1999 to that in 2002?
Keep it short and to the point. 0.69. What is the ratio of the Taxes (in US$) of Croatia in 2000 to that in 2001?
Your response must be concise. 0.93. What is the ratio of the Taxes (in US$) of Grenada in 2000 to that in 2001?
Offer a terse response. 1.06. What is the ratio of the Taxes (in US$) in India in 2000 to that in 2001?
Offer a very short reply. 0.98. What is the ratio of the Taxes (in US$) in Korea (Republic) in 2000 to that in 2001?
Give a very brief answer. 0.89. What is the ratio of the Taxes (in US$) of Croatia in 2000 to that in 2002?
Offer a terse response. 0.85. What is the ratio of the Taxes (in US$) of Grenada in 2000 to that in 2002?
Ensure brevity in your answer.  1.01. What is the ratio of the Taxes (in US$) of India in 2000 to that in 2002?
Your response must be concise. 0.92. What is the ratio of the Taxes (in US$) in Korea (Republic) in 2000 to that in 2002?
Your answer should be very brief. 0.79. What is the ratio of the Taxes (in US$) of Croatia in 2001 to that in 2002?
Provide a short and direct response. 0.92. What is the ratio of the Taxes (in US$) of Grenada in 2001 to that in 2002?
Ensure brevity in your answer.  0.96. What is the ratio of the Taxes (in US$) in India in 2001 to that in 2002?
Your response must be concise. 0.94. What is the ratio of the Taxes (in US$) in Korea (Republic) in 2001 to that in 2002?
Keep it short and to the point. 0.88. What is the difference between the highest and the second highest Taxes (in US$) in Croatia?
Ensure brevity in your answer.  2.80e+09. What is the difference between the highest and the second highest Taxes (in US$) in Grenada?
Ensure brevity in your answer.  2.85e+06. What is the difference between the highest and the second highest Taxes (in US$) in India?
Your response must be concise. 1.19e+11. What is the difference between the highest and the second highest Taxes (in US$) of Korea (Republic)?
Your answer should be compact. 1.01e+13. What is the difference between the highest and the lowest Taxes (in US$) of Croatia?
Your response must be concise. 1.59e+1. What is the difference between the highest and the lowest Taxes (in US$) of Grenada?
Offer a very short reply. 7.71e+07. What is the difference between the highest and the lowest Taxes (in US$) in India?
Ensure brevity in your answer.  8.43e+11. What is the difference between the highest and the lowest Taxes (in US$) of Korea (Republic)?
Ensure brevity in your answer.  4.35e+13. 